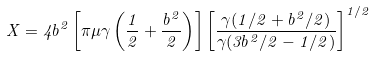Convert formula to latex. <formula><loc_0><loc_0><loc_500><loc_500>X = 4 b ^ { 2 } \left [ \pi \mu \gamma \left ( \frac { 1 } { 2 } + \frac { b ^ { 2 } } 2 \right ) \right ] \left [ \frac { \gamma ( 1 / 2 + b ^ { 2 } / 2 ) } { \gamma ( 3 b ^ { 2 } / 2 - 1 / 2 ) } \right ] ^ { 1 / 2 }</formula> 